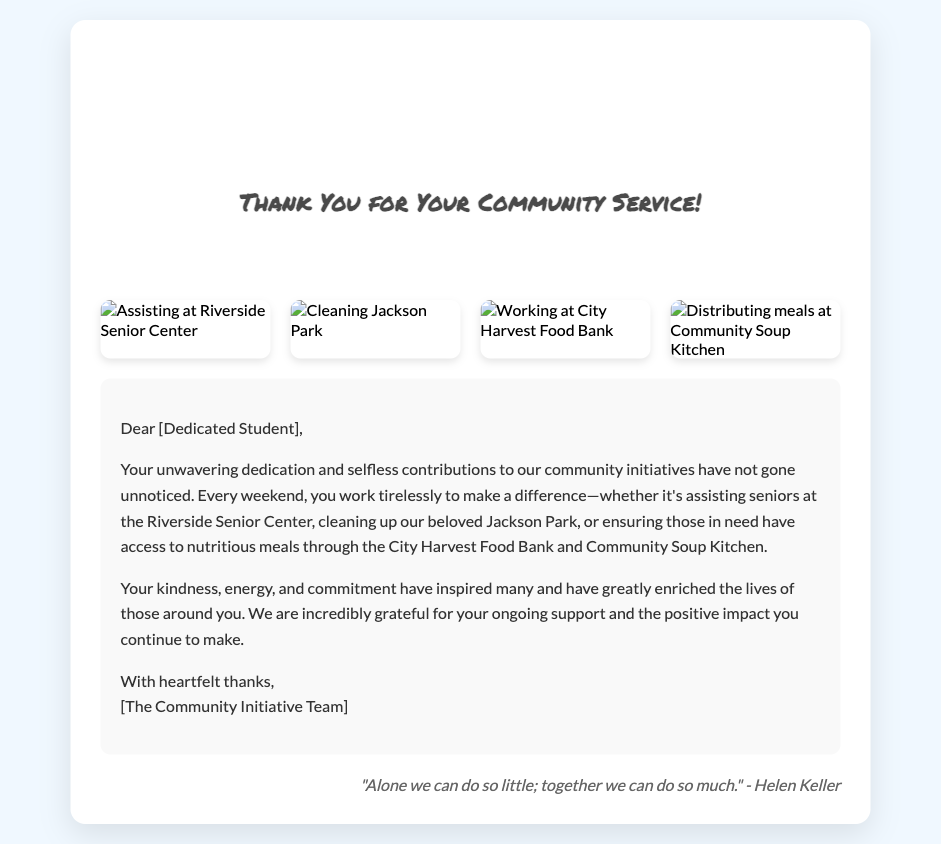What is the title of the card? The title of the card is prominently displayed in the card cover section.
Answer: Thank You for Your Community Service! Who is the card addressed to? The card addresses the recipient in a friendly manner.
Answer: Dedicated Student Which senior center is mentioned in the card? The card references a specific location where community service is performed.
Answer: Riverside Senior Center What are the images in the gallery demonstrating? The images illustrate various community service activities performed by the student.
Answer: Community service activities What quote is included at the bottom of the card? The quote is provided in the card footer and reflects a collaboration theme.
Answer: "Alone we can do so little; together we can do so much." - Helen Keller How many images are displayed in the image gallery? The document lists a specific number of visual representations related to community service.
Answer: Four 